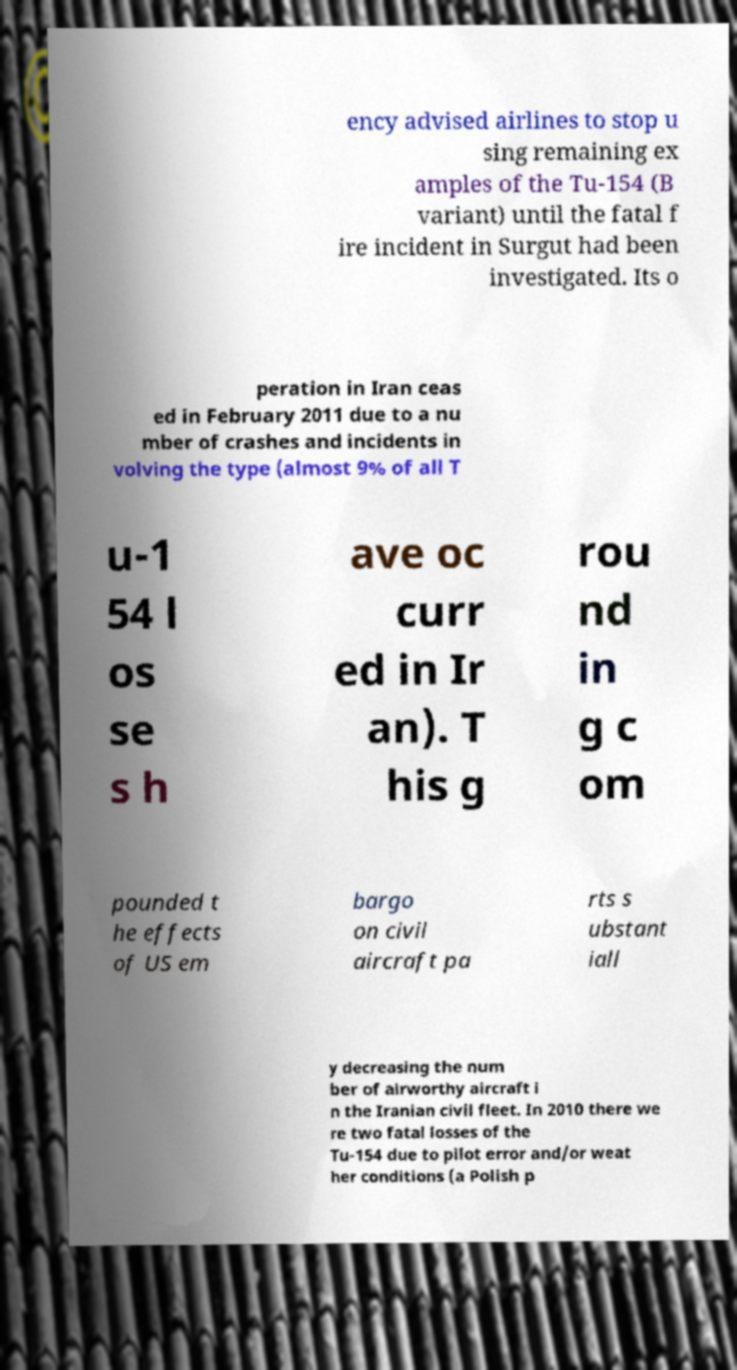Please read and relay the text visible in this image. What does it say? ency advised airlines to stop u sing remaining ex amples of the Tu-154 (B variant) until the fatal f ire incident in Surgut had been investigated. Its o peration in Iran ceas ed in February 2011 due to a nu mber of crashes and incidents in volving the type (almost 9% of all T u-1 54 l os se s h ave oc curr ed in Ir an). T his g rou nd in g c om pounded t he effects of US em bargo on civil aircraft pa rts s ubstant iall y decreasing the num ber of airworthy aircraft i n the Iranian civil fleet. In 2010 there we re two fatal losses of the Tu-154 due to pilot error and/or weat her conditions (a Polish p 